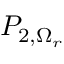<formula> <loc_0><loc_0><loc_500><loc_500>P _ { 2 , \Omega _ { r } }</formula> 